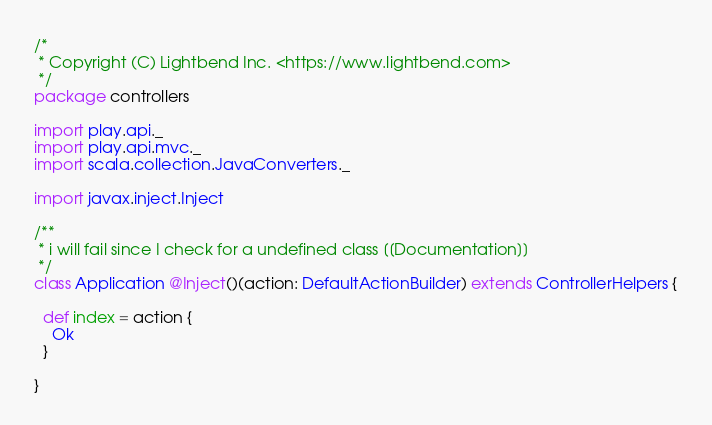<code> <loc_0><loc_0><loc_500><loc_500><_Scala_>/*
 * Copyright (C) Lightbend Inc. <https://www.lightbend.com>
 */
package controllers

import play.api._
import play.api.mvc._
import scala.collection.JavaConverters._

import javax.inject.Inject

/**
 * i will fail since I check for a undefined class [[Documentation]]
 */
class Application @Inject()(action: DefaultActionBuilder) extends ControllerHelpers {

  def index = action {
    Ok
  }

}
</code> 